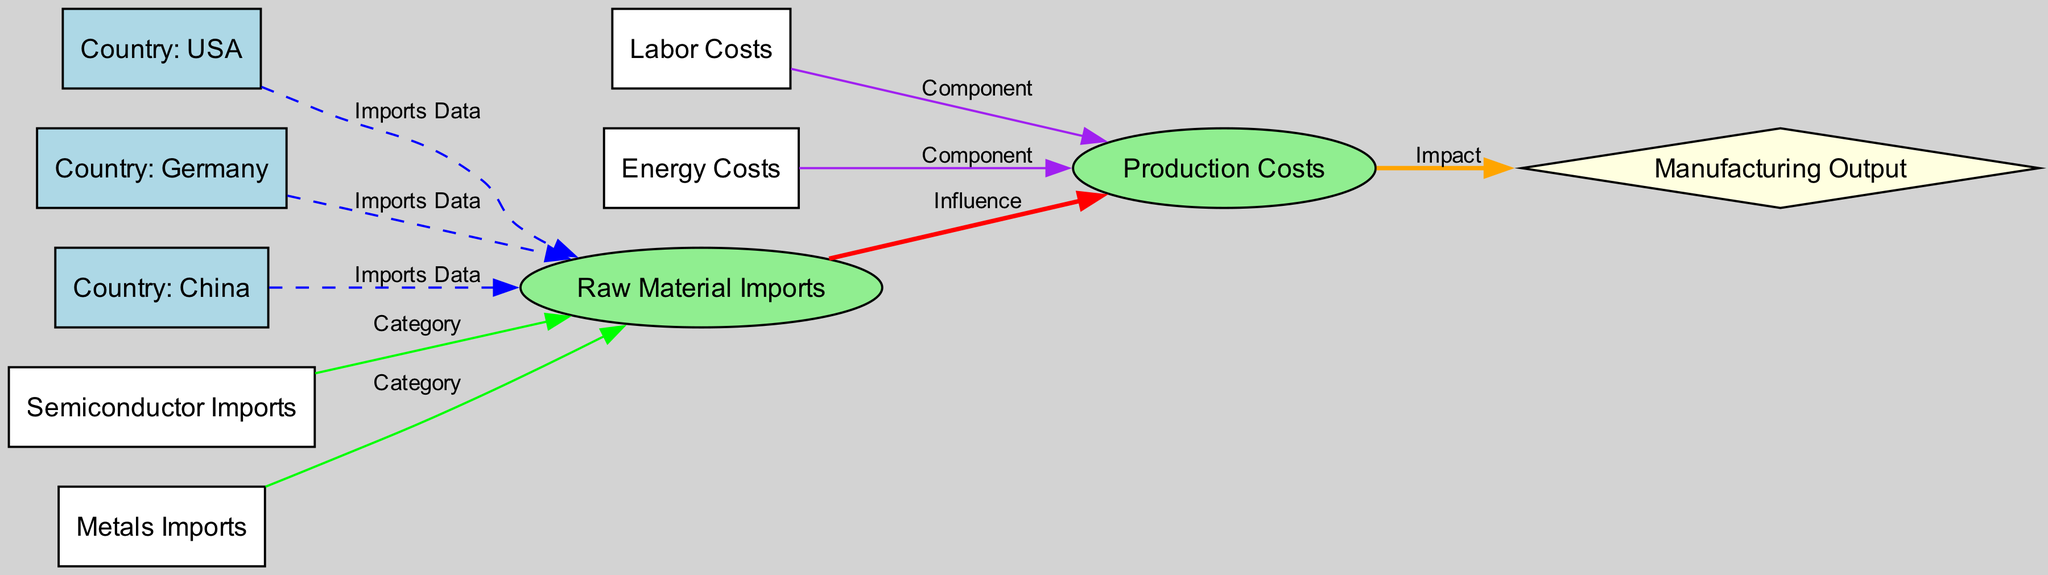What are the main categories of raw material imports in the electronics sector? The diagram shows two categories of raw material imports: semiconductor imports and metals imports, which are represented by their respective nodes connecting to the raw material imports node.
Answer: Semiconductor imports, metals imports Which countries are represented in the diagram? The diagram features three countries, each represented by a node labeled with their names: USA, Germany, and China. These nodes are connected to the raw material imports node.
Answer: USA, Germany, China How many nodes are there in total? The total count of nodes can be found by counting all the distinct entities represented in the diagram. There are nine nodes: raw material imports, production costs, USA, Germany, China, semiconductor imports, metals imports, labor costs, energy costs, and manufacturing output.
Answer: Nine nodes What influence does raw material imports have on production costs? The edge labeled "Influence" connects the raw material imports node to the production costs node, indicating a direct influence of raw material imports on production costs in the electronics sector.
Answer: Influence What are the components that contribute to production costs? The diagram indicates that labor costs and energy costs are the components that directly affect production costs, as depicted by the edges labeled "Component" connecting to the production costs node.
Answer: Labor costs, energy costs What is the final output affected by production costs? The production costs node has an edge labeled "Impact" connecting to the manufacturing output node, signifying that production costs have a direct impact on manufacturing output.
Answer: Manufacturing output How does semiconductor imports relate to raw material imports? The relationship is categorized as "Category," which suggests that semiconductor imports are a specific category of raw material imports, indicated by the edge that connects semiconductor imports to raw material imports.
Answer: Category Which costs have a direct impact on production costs? The diagram details that both labor costs and energy costs directly impact production costs, as they are linked to the production costs node with edges labeled "Component."
Answer: Labor costs, energy costs What type of edges connect the countries to raw material imports? The edges connecting the country nodes (USA, Germany, China) to the raw material imports node are labeled "Imports Data," indicating that the connections represent data related to imports.
Answer: Imports Data 